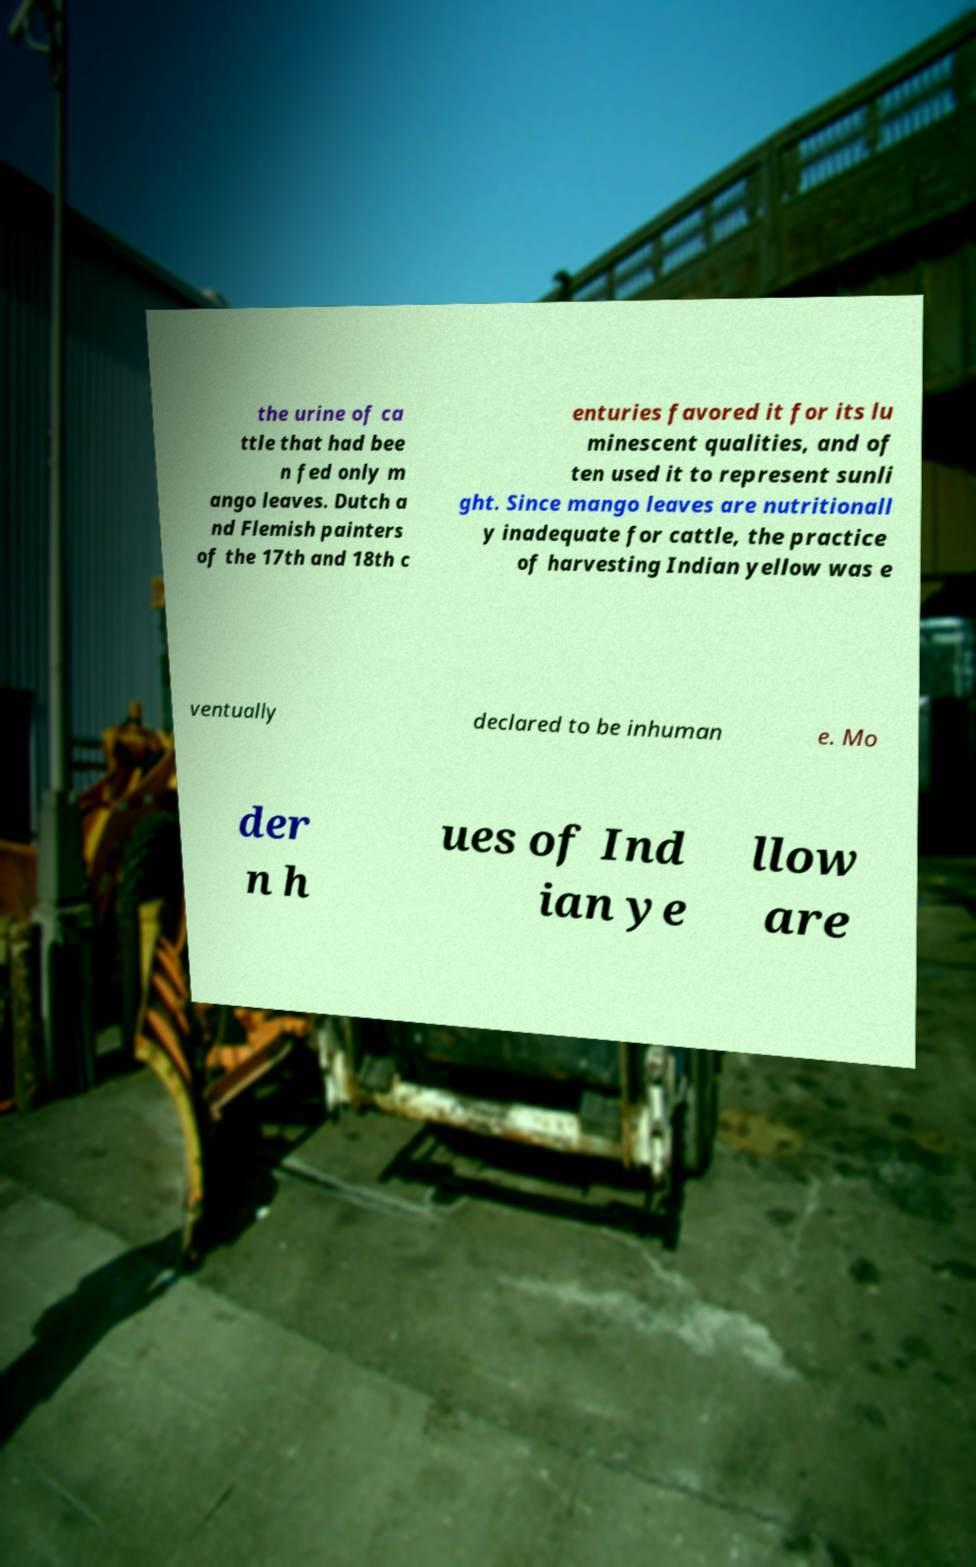I need the written content from this picture converted into text. Can you do that? the urine of ca ttle that had bee n fed only m ango leaves. Dutch a nd Flemish painters of the 17th and 18th c enturies favored it for its lu minescent qualities, and of ten used it to represent sunli ght. Since mango leaves are nutritionall y inadequate for cattle, the practice of harvesting Indian yellow was e ventually declared to be inhuman e. Mo der n h ues of Ind ian ye llow are 